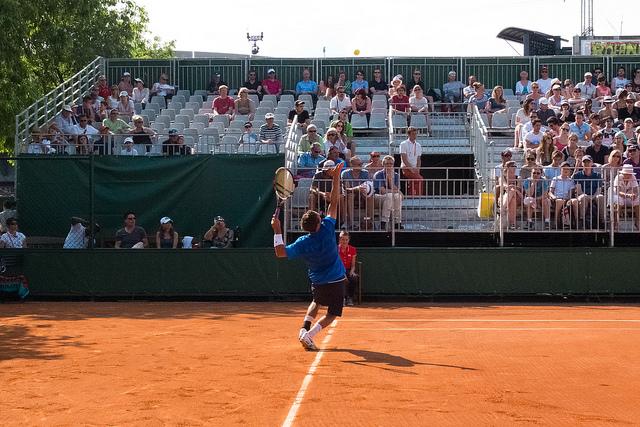What color are the man's shorts?
Answer briefly. Black. Is the spectator section full?
Concise answer only. No. What is the man in the foreground holding?
Quick response, please. Racket. Does the weather appear sunny?
Concise answer only. Yes. 